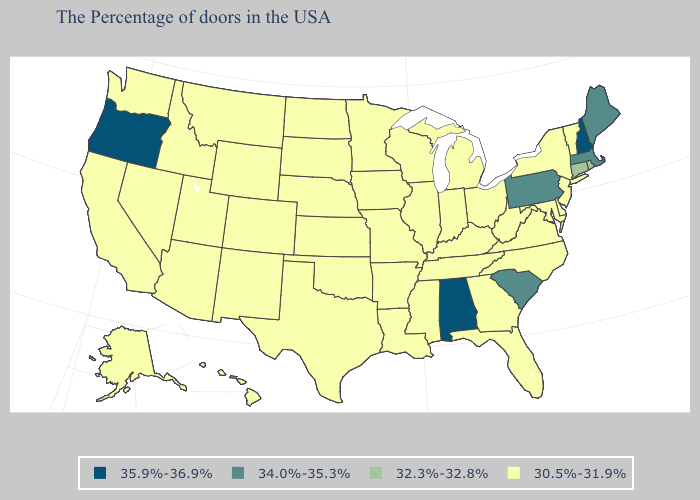Among the states that border North Carolina , does South Carolina have the lowest value?
Quick response, please. No. Does Washington have the lowest value in the USA?
Keep it brief. Yes. Which states have the highest value in the USA?
Quick response, please. New Hampshire, Alabama, Oregon. Which states have the lowest value in the South?
Answer briefly. Delaware, Maryland, Virginia, North Carolina, West Virginia, Florida, Georgia, Kentucky, Tennessee, Mississippi, Louisiana, Arkansas, Oklahoma, Texas. Name the states that have a value in the range 32.3%-32.8%?
Concise answer only. Rhode Island, Connecticut. Which states have the highest value in the USA?
Quick response, please. New Hampshire, Alabama, Oregon. What is the lowest value in the West?
Quick response, please. 30.5%-31.9%. Name the states that have a value in the range 34.0%-35.3%?
Give a very brief answer. Maine, Massachusetts, Pennsylvania, South Carolina. Name the states that have a value in the range 34.0%-35.3%?
Answer briefly. Maine, Massachusetts, Pennsylvania, South Carolina. Which states have the lowest value in the USA?
Short answer required. Vermont, New York, New Jersey, Delaware, Maryland, Virginia, North Carolina, West Virginia, Ohio, Florida, Georgia, Michigan, Kentucky, Indiana, Tennessee, Wisconsin, Illinois, Mississippi, Louisiana, Missouri, Arkansas, Minnesota, Iowa, Kansas, Nebraska, Oklahoma, Texas, South Dakota, North Dakota, Wyoming, Colorado, New Mexico, Utah, Montana, Arizona, Idaho, Nevada, California, Washington, Alaska, Hawaii. What is the lowest value in the South?
Concise answer only. 30.5%-31.9%. What is the value of Mississippi?
Short answer required. 30.5%-31.9%. What is the lowest value in the USA?
Concise answer only. 30.5%-31.9%. How many symbols are there in the legend?
Short answer required. 4. 